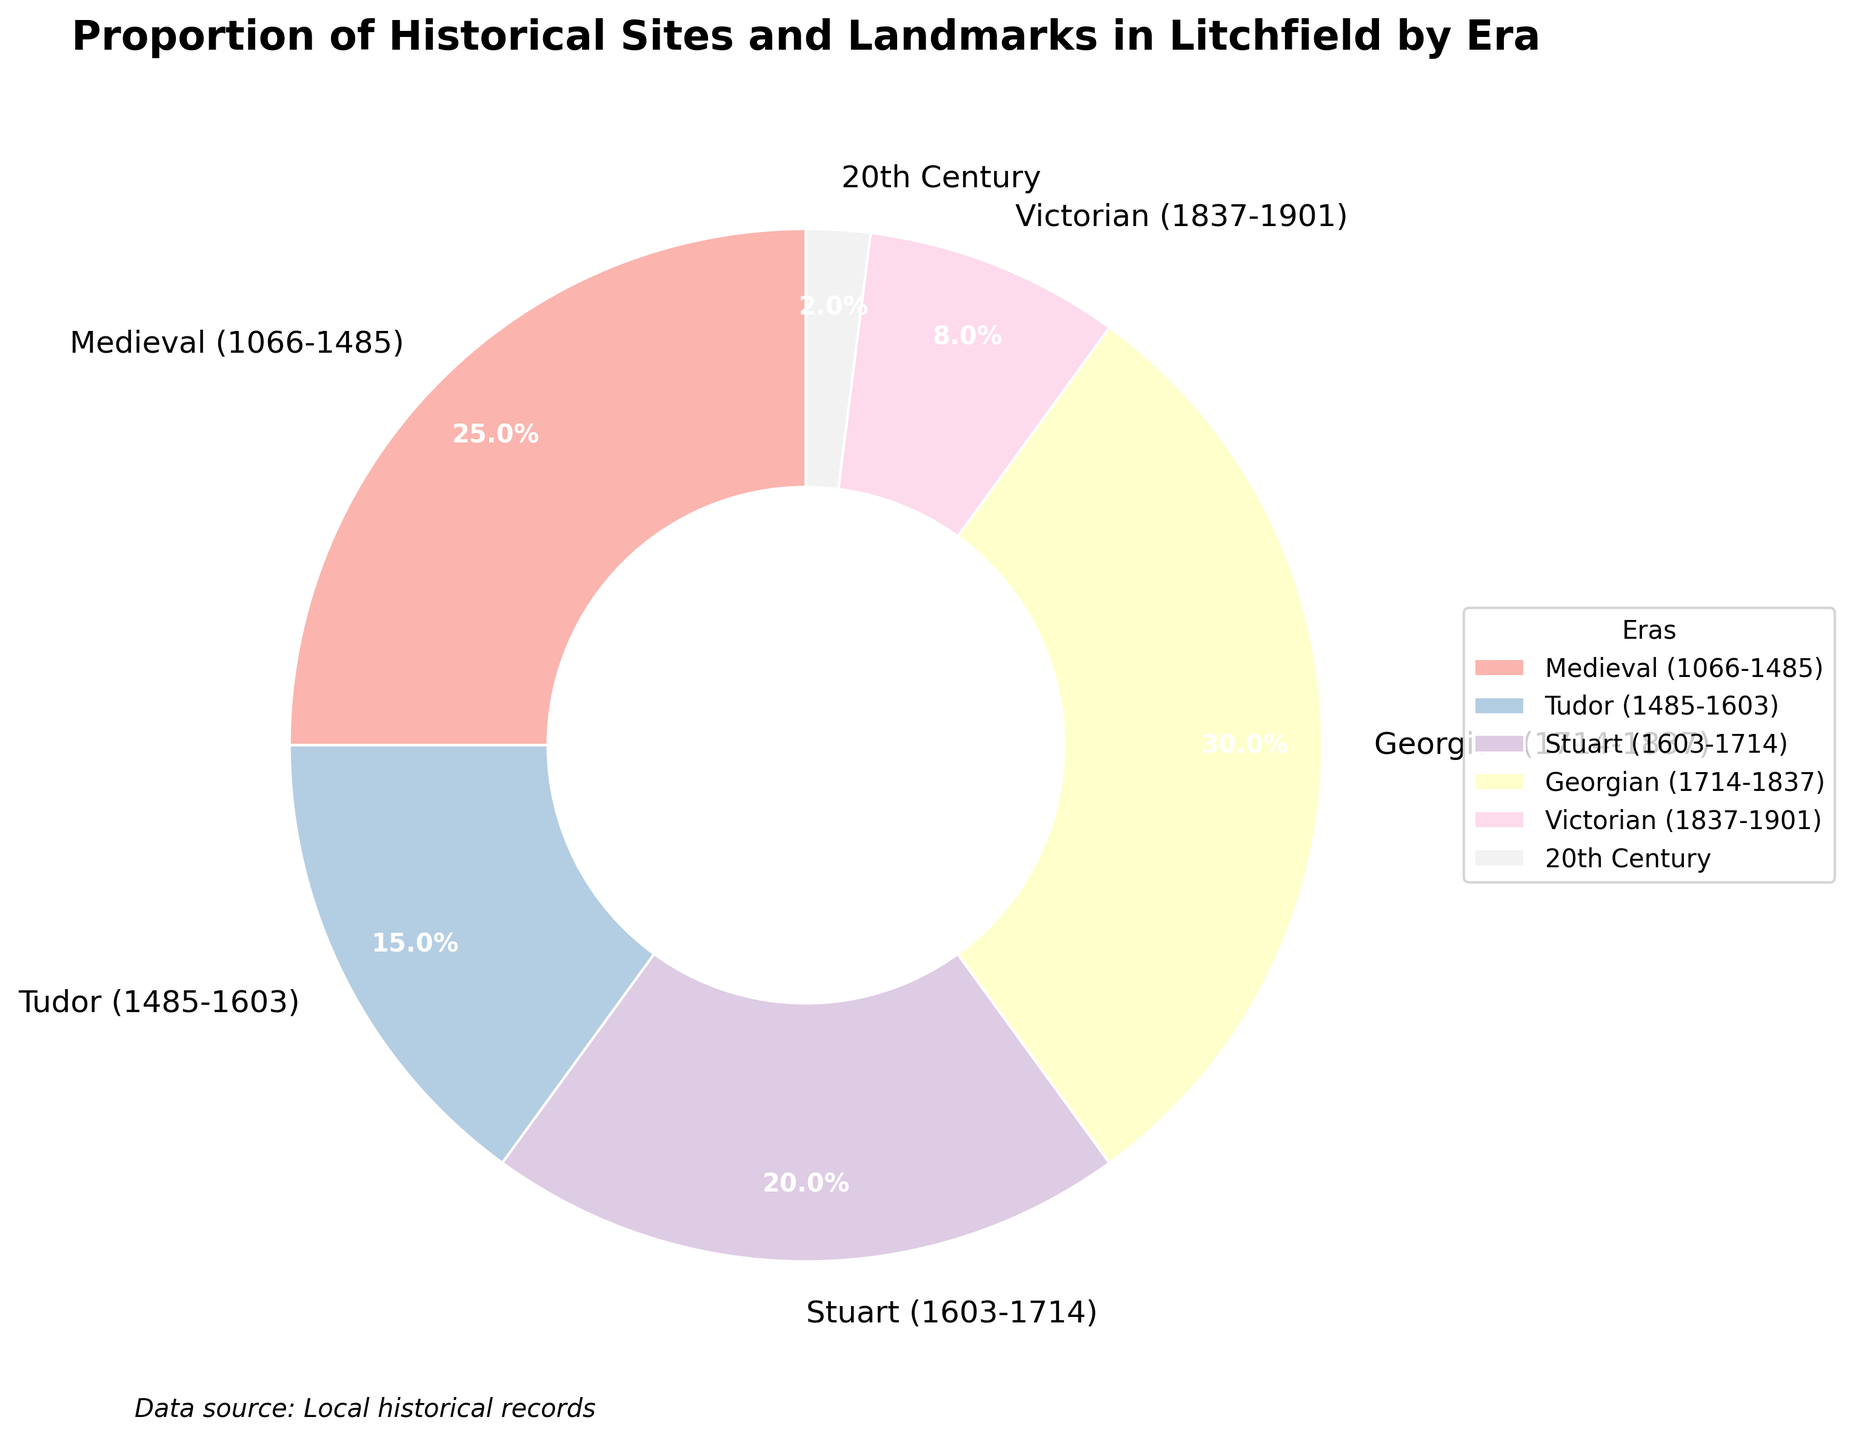what is the title of the plot? The title is usually located at the top of the figure and provides a summary of what the plot represents. The title in this case reads: "Proportion of Historical Sites and Landmarks in Litchfield by Era"
Answer: Proportion of Historical Sites and Landmarks in Litchfield by Era How many eras are represented in the pie chart? The pie chart includes slices for each era, and the labels indicate the number of unique categories. Counting these labeled slices gives the total number of eras.
Answer: Six Which era has the largest proportion of historical sites and landmarks? The largest proportion can be identified by comparing the sizes of the slices in the pie chart. The label with the highest percentage indicates the era with the largest proportion.
Answer: Georgian (1714-1837) What is the combined proportion of historical sites and landmarks for the Medieval and Stuart eras? To find the combined proportion, add the percentages for the Medieval and Stuart eras. The Medieval era is 25% and the Stuart era is 20%, so their combined proportion is 25% + 20%.
Answer: 45% How does the proportion of the Victorian era compare to the proportion of the 20th Century? In a pie chart, slices can be compared to determine relative sizes. The Victorian era slice is 8%, while the 20th Century slice is 2%. To compare them, you can subtract the proportion of the 20th Century from that of the Victorian era: 8% - 2%.
Answer: 6% larger Which eras have a smaller proportion of historical sites and landmarks than the Stuart era? The Stuart era has a proportion of 20%. By comparing this value to the proportions of other eras, the smaller ones can be identified: Tudor (15%), Victorian (8%), 20th Century (2%).
Answer: Tudor, Victorian, 20th Century What is the difference in proportions between the era with the lowest and the era with the highest proportion of historical sites and landmarks? The highest proportion is the Georgian era with 30%, and the lowest is the 20th Century with 2%. Subtracting the smallest proportion from the largest gives: 30% - 2%.
Answer: 28% Which eras have a proportion greater than 20%? By comparing each era's proportion to 20%, the eras with larger proportions can be identified. The Medieval era is 25% and the Georgian era is 30%, both greater than 20%.
Answer: Medieval, Georgian 